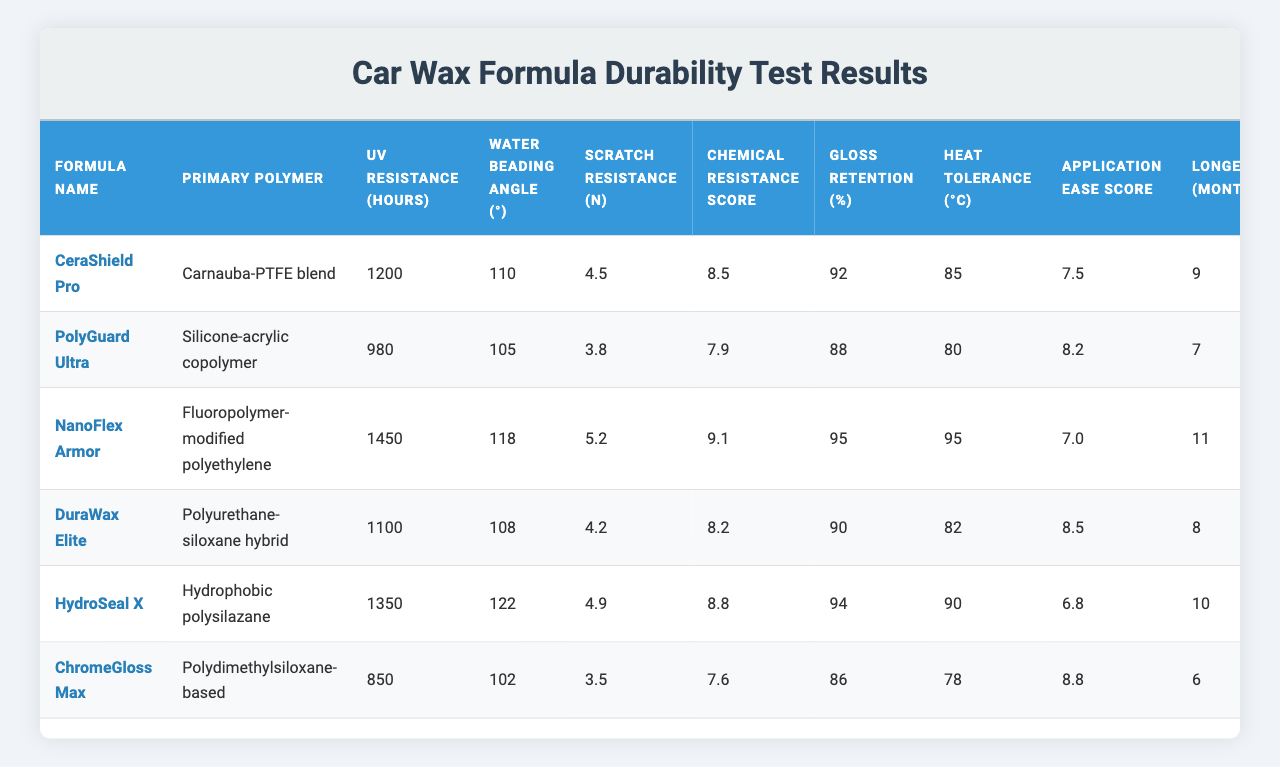What is the UV resistance of the "NanoFlex Armor" formula? The UV resistance for "NanoFlex Armor" is listed in the table under the relevant column, which shows 1450 hours.
Answer: 1450 hours Which formula has the highest scratch resistance? By comparing the "Scratch Resistance (N)" column, "NanoFlex Armor" has the highest value of 5.2 N.
Answer: NanoFlex Armor What is the longevity of the "ChromeGloss Max" formula? The "Longevity (months)" column shows that "ChromeGloss Max" has a longevity of 6 months.
Answer: 6 months How does the water beading angle of "HydroSeal X" compare to "DuraWax Elite"? "HydroSeal X" has a water beading angle of 122 degrees, while "DuraWax Elite" has 108 degrees. To compare, it is necessary to see that 122 degrees is greater than 108 degrees.
Answer: HydroSeal X has a greater angle What is the average longevity of all the formulas? Summing the "Longevity (months)" values gives us 9 + 7 + 11 + 8 + 10 + 6 = 51 months. Dividing by the number of formulas (6), 51/6 = 8.5 months is the average longevity.
Answer: 8.5 months Is the chemical resistance score of "PolyGuard Ultra" above 8? The table indicates that "PolyGuard Ultra" has a chemical resistance score of 7.9, which is below 8 when compared.
Answer: No Which formula has the highest heat tolerance combined with the highest gloss retention percentage? Analyzing the "Heat Tolerance (°C)" and "Gloss Retention (%)" columns, "NanoFlex Armor" has the highest heat tolerance of 95 °C and the highest gloss retention of 95%, making it the best in both categories.
Answer: NanoFlex Armor If we sum the chemical resistance scores of all formulas, what is the total? The chemical resistance scores are 8.5, 7.9, 9.1, 8.2, 8.8, and 7.6. Summing these gives 8.5 + 7.9 + 9.1 + 8.2 + 8.8 + 7.6 = 50.1 for the total score.
Answer: 50.1 Which polymer does "DuraWax Elite" use, and is it a hybrid type? The table states that "DuraWax Elite" uses a "Polyurethane-siloxane hybrid," which confirms it is indeed a hybrid type.
Answer: Yes, it is a hybrid type How many formulas have a longevity of 9 months or more? The longevity column shows that "CeraShield Pro" (9 months), "NanoFlex Armor" (11 months), "HydroSeal X" (10 months), and "DuraWax Elite" (8 months but does not count). Thus 3 formulas meet the criteria.
Answer: 3 formulas Is the average application ease score greater than 8? The application ease scores are 7.5, 8.2, 7.0, 8.5, 6.8, and 8.8. Summing these gives 46.8 and dividing by 6 results in an average of 7.8, which is below 8.
Answer: No 